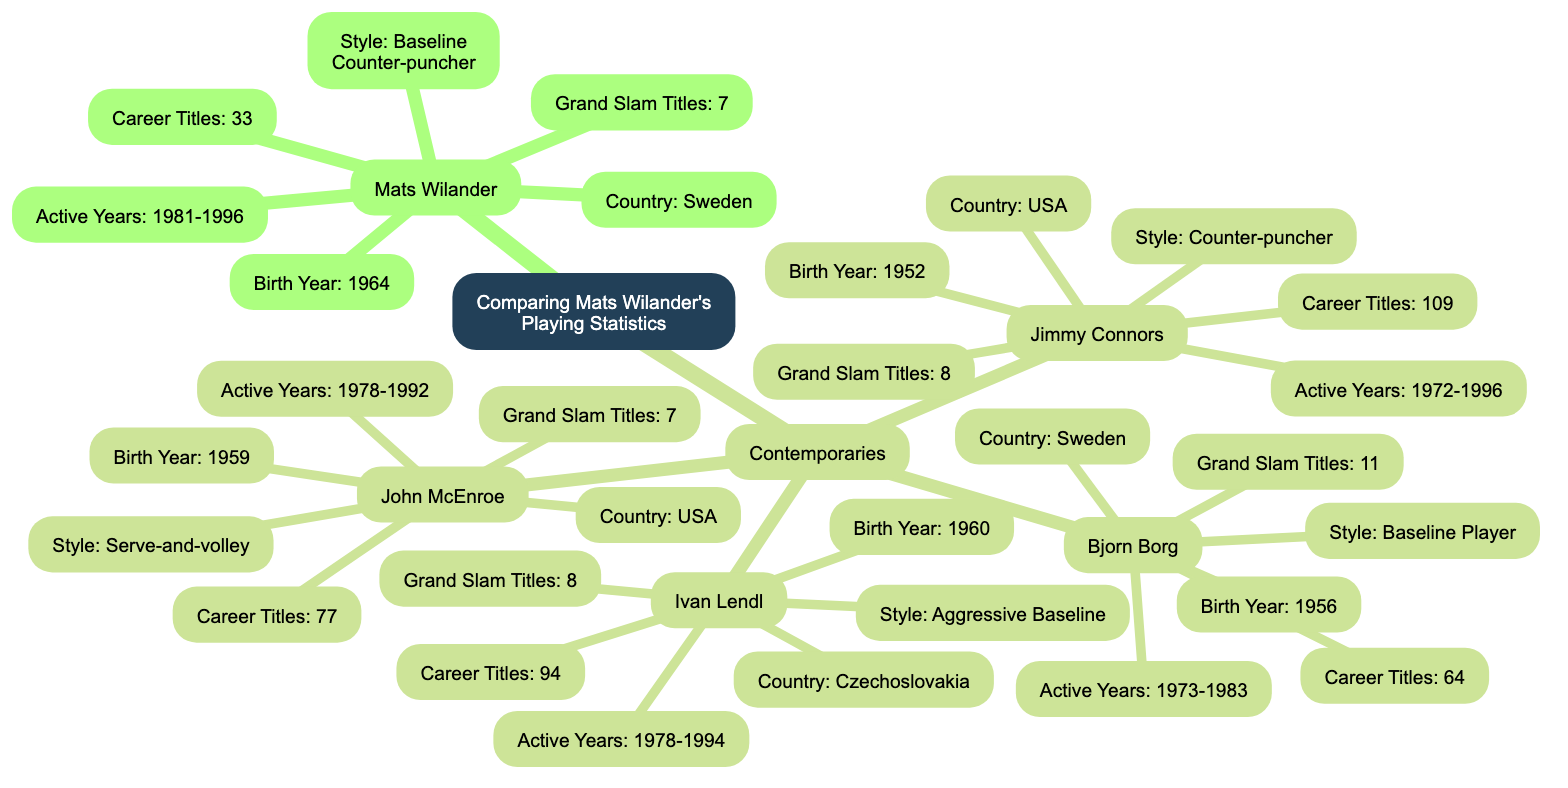What are the total Grand Slam titles won by Mats Wilander? According to the diagram, the node under "Mats Wilander" labeled "Grand Slam Titles" states that he has a total of 7 titles.
Answer: 7 How many career titles does Jimmy Connors have? The diagram shows the node for "Jimmy Connors," under which the "Career Titles" node indicates he has a total of 109 titles.
Answer: 109 What is the playing style of Ivan Lendl? The diagram indicates Ivan Lendl's playing style is listed under his node; it specifically states he is an "aggressive baseline" player.
Answer: aggressive baseline Which player has the highest number of career titles among the contemporaries? By examining the "Career Titles" nodes for all contemporaries, Jimmy Connors has 109 titles, which is higher than the others listed (e.g., Borg has 64, Lendl has 94, and McEnroe has 77).
Answer: 109 Who has more Grand Slam titles, Mats Wilander or John McEnroe? The diagram clearly shows that Mats Wilander has 7 Grand Slam titles while John McEnroe also has 7. Thus, they are equal in this statistic.
Answer: equal Which two players have the same number of Grand Slam titles? Looking at the Grand Slam titles for each player, both Jimmy Connors and Ivan Lendl have 8 Grand Slam titles listed, which means they are equal.
Answer: Connors and Lendl How many players are listed as contemporaries of Mats Wilander? The "Contemporaries" node includes four players: Bjorn Borg, Ivan Lendl, Jimmy Connors, and John McEnroe. Thus, the total number of players is four.
Answer: 4 What is the birth year of Bjorn Borg? The diagram features the node under "Bjorn Borg," which states his birth year is 1956.
Answer: 1956 Which player has a higher number of Grand Slam titles, Mats Wilander or Bjorn Borg? Reviewing the Grand Slam titles, Bjorn Borg has 11 titles, whereas Mats Wilander has 7. Therefore, Borg has a higher count.
Answer: Borg 